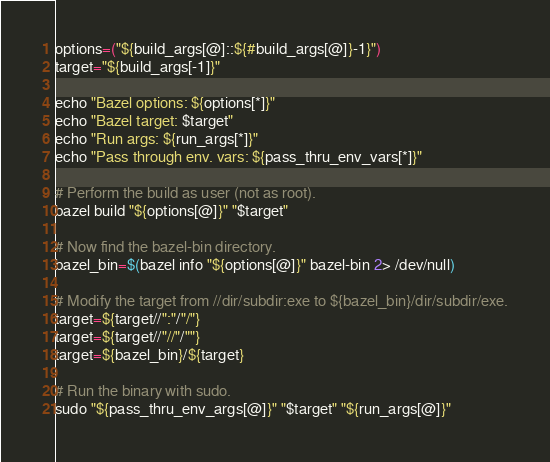<code> <loc_0><loc_0><loc_500><loc_500><_Bash_>
options=("${build_args[@]::${#build_args[@]}-1}")
target="${build_args[-1]}"

echo "Bazel options: ${options[*]}"
echo "Bazel target: $target"
echo "Run args: ${run_args[*]}"
echo "Pass through env. vars: ${pass_thru_env_vars[*]}"

# Perform the build as user (not as root).
bazel build "${options[@]}" "$target"

# Now find the bazel-bin directory.
bazel_bin=$(bazel info "${options[@]}" bazel-bin 2> /dev/null)

# Modify the target from //dir/subdir:exe to ${bazel_bin}/dir/subdir/exe.
target=${target//":"/"/"}
target=${target//"//"/""}
target=${bazel_bin}/${target}

# Run the binary with sudo.
sudo "${pass_thru_env_args[@]}" "$target" "${run_args[@]}"
</code> 